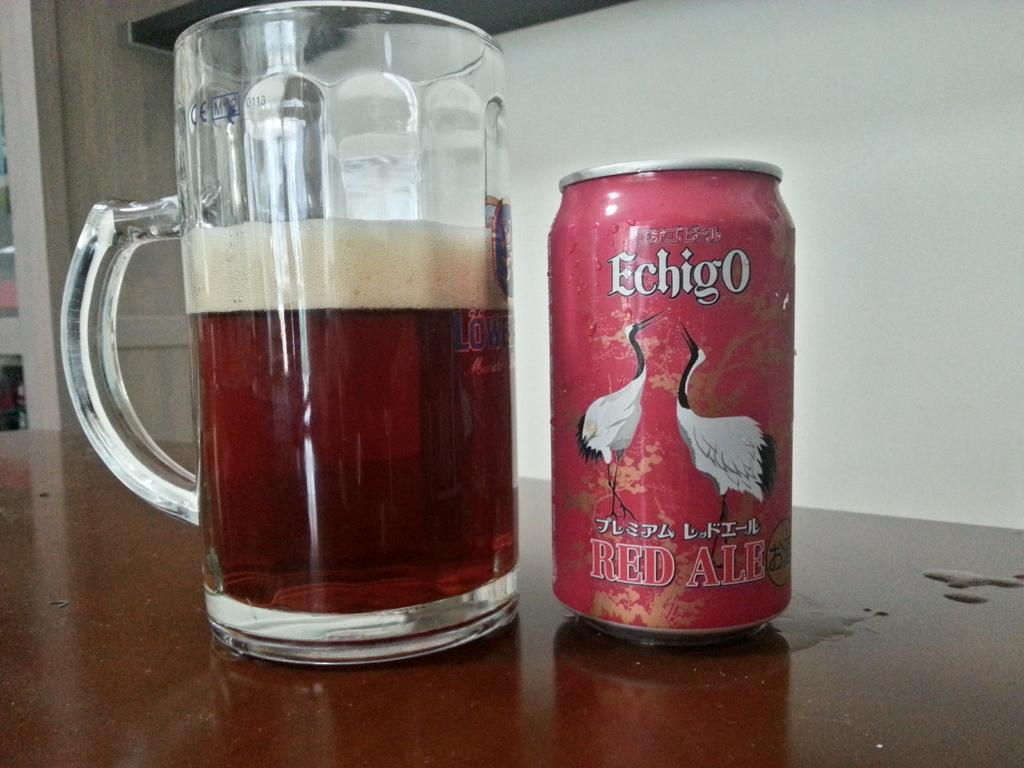Provide a one-sentence caption for the provided image. A can of Echigo Red Ale next to a tall mug filled with presumably the same drink. 